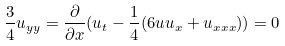<formula> <loc_0><loc_0><loc_500><loc_500>\frac { 3 } { 4 } u _ { y y } = \frac { \partial } { \partial x } ( u _ { t } - \frac { 1 } { 4 } ( 6 u u _ { x } + u _ { x x x } ) ) = 0</formula> 